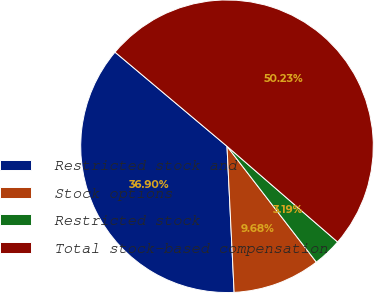<chart> <loc_0><loc_0><loc_500><loc_500><pie_chart><fcel>Restricted stock and<fcel>Stock options<fcel>Restricted stock<fcel>Total stock-based compensation<nl><fcel>36.9%<fcel>9.68%<fcel>3.19%<fcel>50.23%<nl></chart> 